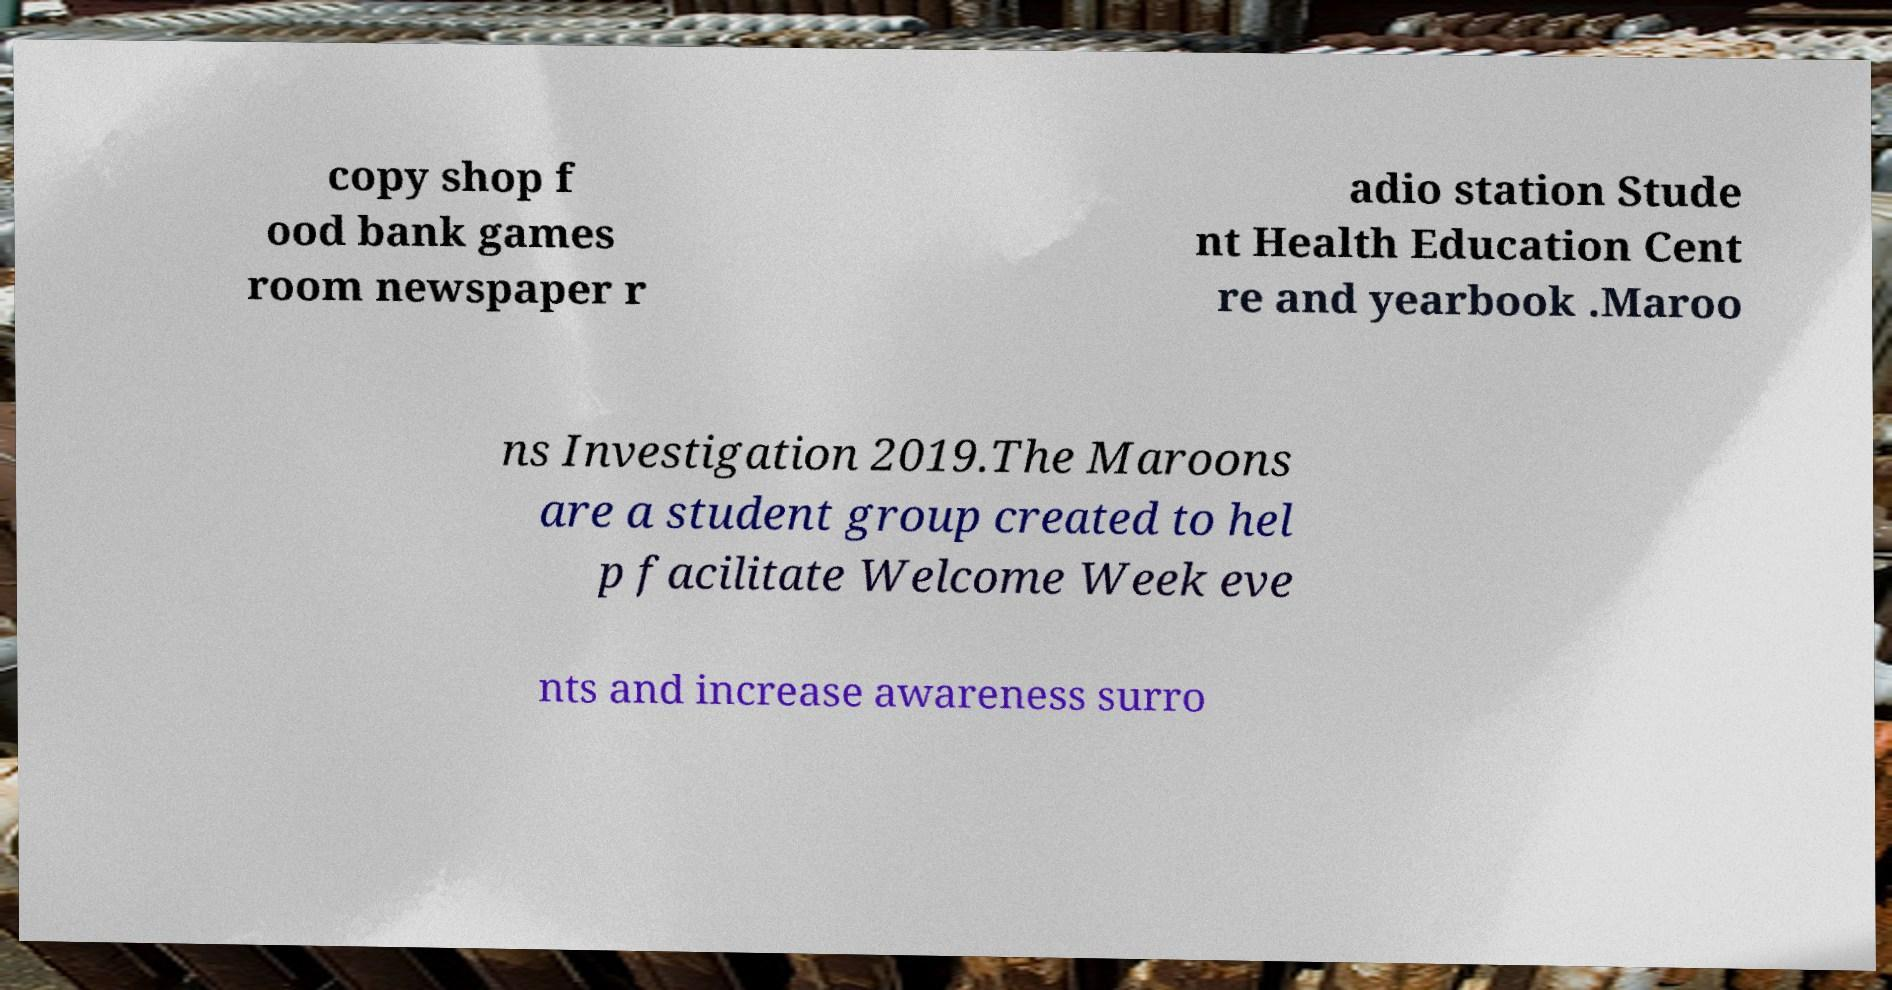For documentation purposes, I need the text within this image transcribed. Could you provide that? copy shop f ood bank games room newspaper r adio station Stude nt Health Education Cent re and yearbook .Maroo ns Investigation 2019.The Maroons are a student group created to hel p facilitate Welcome Week eve nts and increase awareness surro 